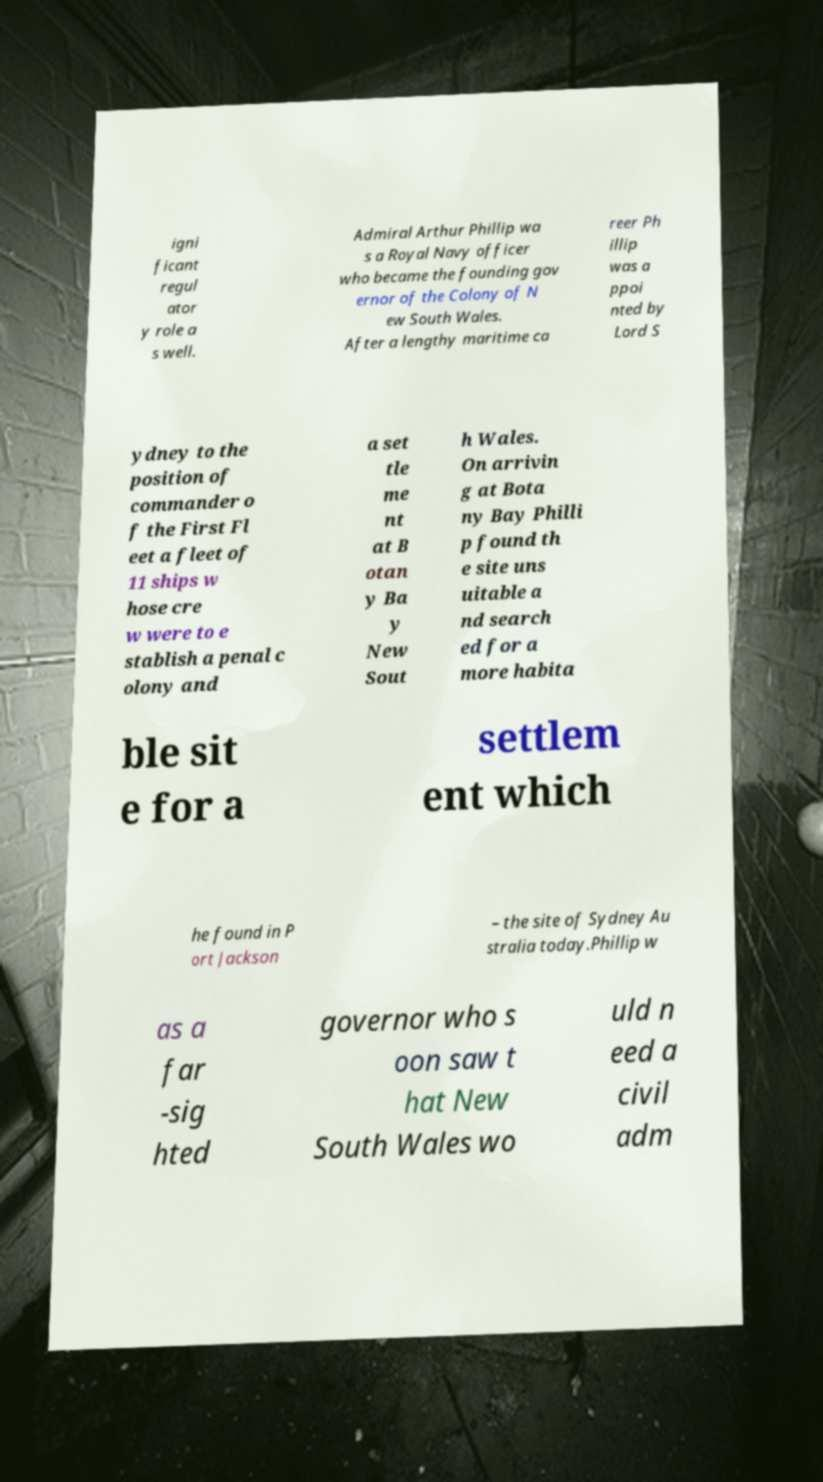Could you extract and type out the text from this image? igni ficant regul ator y role a s well. Admiral Arthur Phillip wa s a Royal Navy officer who became the founding gov ernor of the Colony of N ew South Wales. After a lengthy maritime ca reer Ph illip was a ppoi nted by Lord S ydney to the position of commander o f the First Fl eet a fleet of 11 ships w hose cre w were to e stablish a penal c olony and a set tle me nt at B otan y Ba y New Sout h Wales. On arrivin g at Bota ny Bay Philli p found th e site uns uitable a nd search ed for a more habita ble sit e for a settlem ent which he found in P ort Jackson – the site of Sydney Au stralia today.Phillip w as a far -sig hted governor who s oon saw t hat New South Wales wo uld n eed a civil adm 